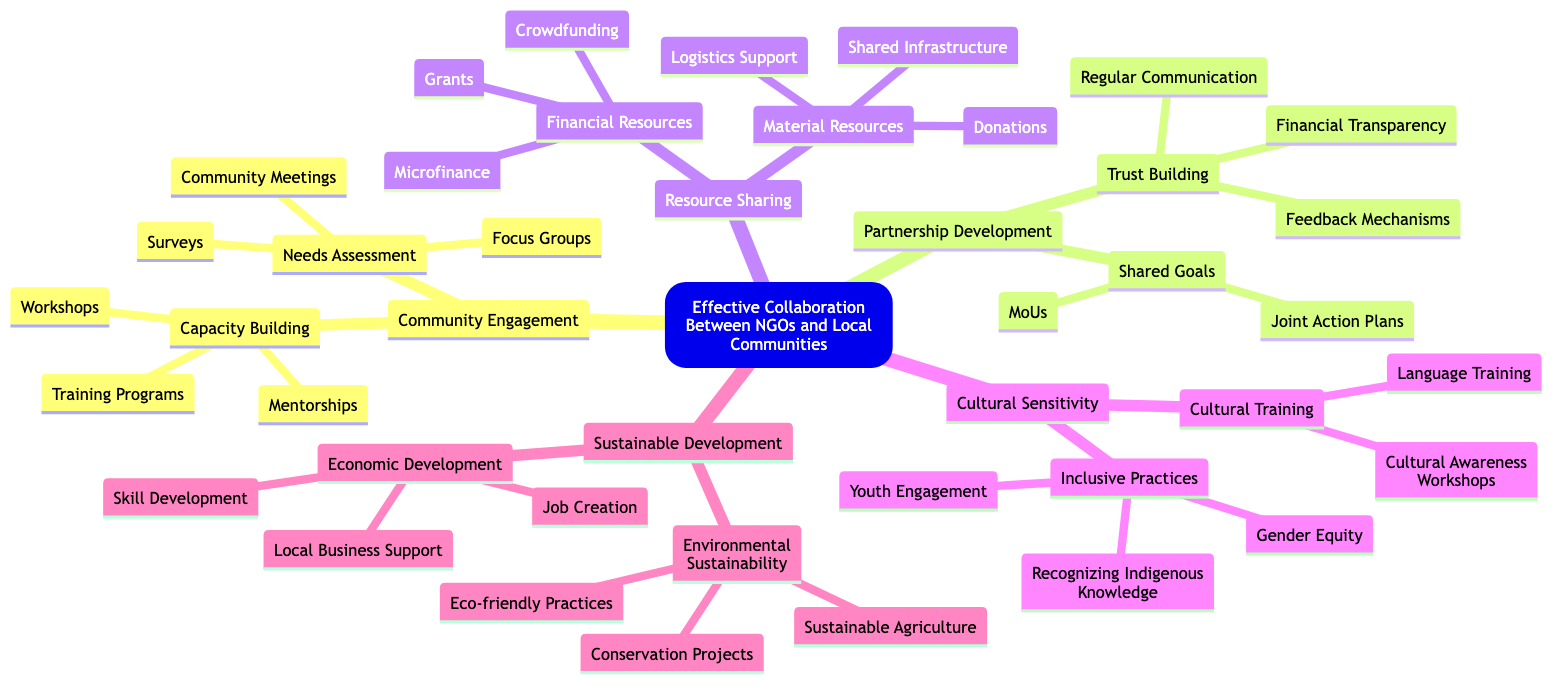What is the central theme of the diagram? The central theme is explicitly stated at the top of the diagram as "Effective Collaboration Between NGOs and Local Communities".
Answer: Effective Collaboration Between NGOs and Local Communities How many main elements are in the diagram? The diagram contains five main elements branching from the central theme which are Community Engagement, Partnership Development, Resource Sharing, Cultural Sensitivity, and Sustainable Development.
Answer: 5 What sub-element falls under Capacity Building? Under Capacity Building, the sub-elements listed are Training Programs, Workshops, and Mentorships, which elaborate on enhancing local skills and resources.
Answer: Training Programs, Workshops, Mentorships What is an entity associated with Financial Resources? The entities associated with Financial Resources include Grants, Microfinance, and Crowdfunding, which pertain to the allocation of funds effectively.
Answer: Grants What relationship exists between Trust Building and Regular Communication? Trust Building is a sub-element of Partnership Development, and Regular Communication is an entity under Trust Building, indicating that fostering trust involves maintaining regular communication.
Answer: Trust Building includes Regular Communication What is one goal of Cultural Sensitivity? One of the goals of Cultural Sensitivity is to ensure inclusive practices that recognize all community groups, showing respect and incorporation of local cultures.
Answer: Respecting and incorporating local cultures Which element focuses on long-term impacts? The element that focuses on long-term impacts is Sustainable Development, which aims at both environmental and economic sustainability through various initiatives.
Answer: Sustainable Development What are the two aspects of Economic Development listed in the diagram? Economic Development has two aspects listed as Job Creation and Local Business Support, indicating a focus on promoting economic self-sufficiency.
Answer: Job Creation, Local Business Support What training is suggested under Cultural Training? The diagram suggests Cultural Awareness Workshops and Language Training as part of Cultural Training for NGO staff, highlighting the importance of understanding local customs.
Answer: Cultural Awareness Workshops, Language Training 